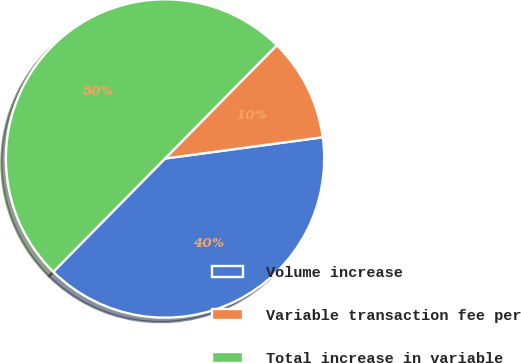Convert chart. <chart><loc_0><loc_0><loc_500><loc_500><pie_chart><fcel>Volume increase<fcel>Variable transaction fee per<fcel>Total increase in variable<nl><fcel>39.52%<fcel>10.48%<fcel>50.0%<nl></chart> 